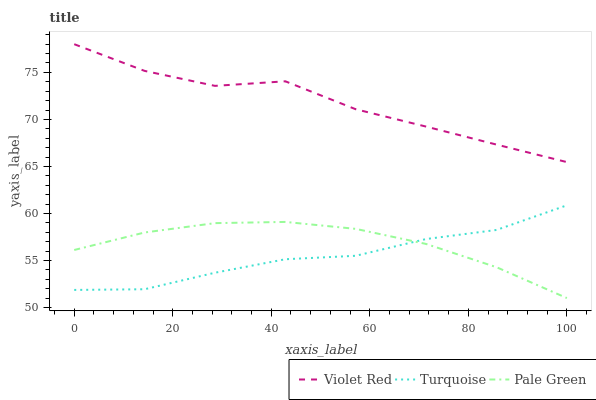Does Turquoise have the minimum area under the curve?
Answer yes or no. Yes. Does Violet Red have the maximum area under the curve?
Answer yes or no. Yes. Does Pale Green have the minimum area under the curve?
Answer yes or no. No. Does Pale Green have the maximum area under the curve?
Answer yes or no. No. Is Pale Green the smoothest?
Answer yes or no. Yes. Is Violet Red the roughest?
Answer yes or no. Yes. Is Turquoise the smoothest?
Answer yes or no. No. Is Turquoise the roughest?
Answer yes or no. No. Does Pale Green have the lowest value?
Answer yes or no. Yes. Does Turquoise have the lowest value?
Answer yes or no. No. Does Violet Red have the highest value?
Answer yes or no. Yes. Does Turquoise have the highest value?
Answer yes or no. No. Is Pale Green less than Violet Red?
Answer yes or no. Yes. Is Violet Red greater than Turquoise?
Answer yes or no. Yes. Does Pale Green intersect Turquoise?
Answer yes or no. Yes. Is Pale Green less than Turquoise?
Answer yes or no. No. Is Pale Green greater than Turquoise?
Answer yes or no. No. Does Pale Green intersect Violet Red?
Answer yes or no. No. 